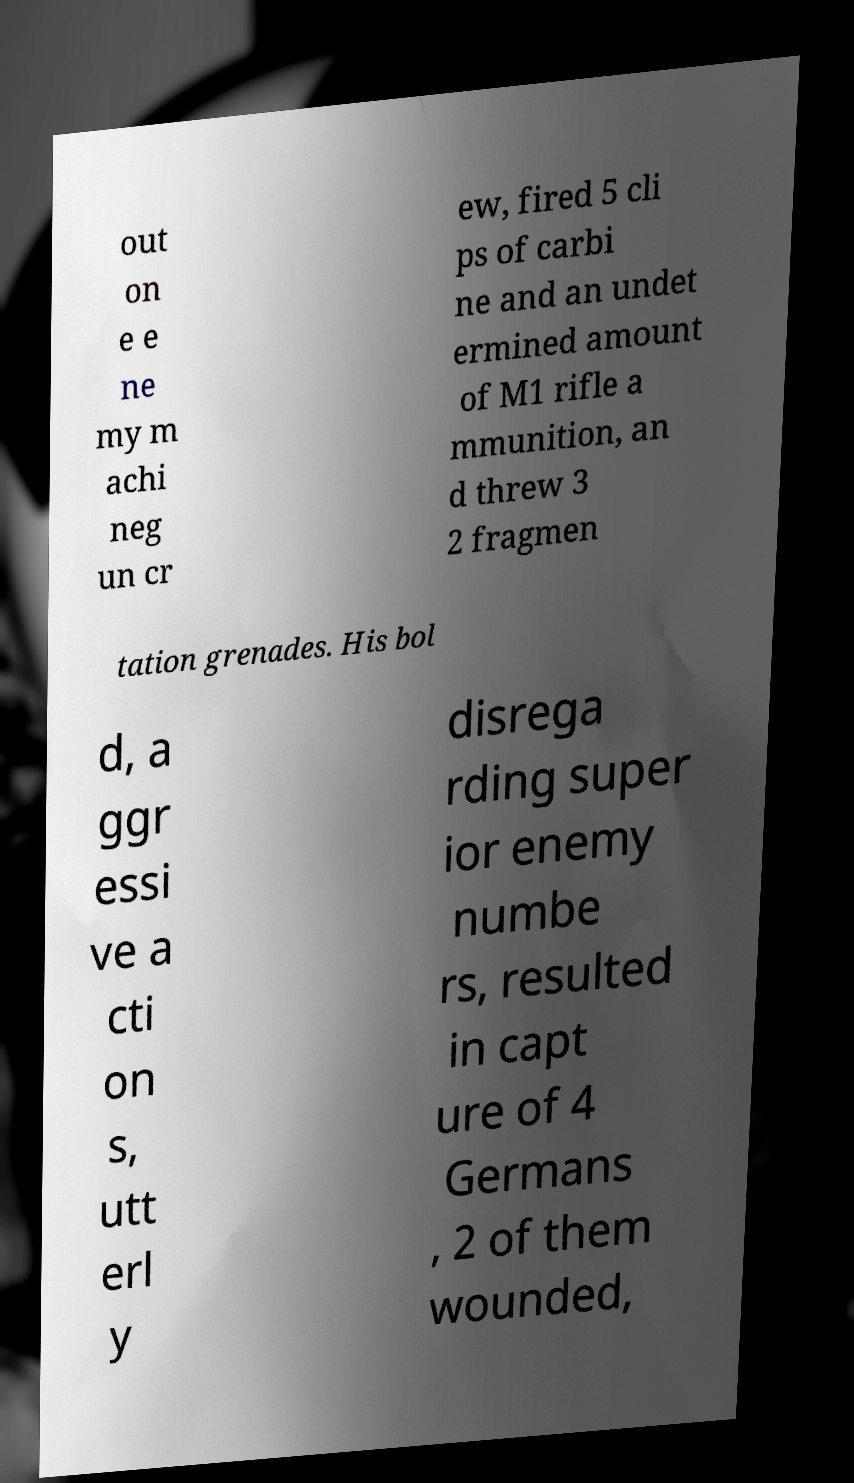Could you extract and type out the text from this image? out on e e ne my m achi neg un cr ew, fired 5 cli ps of carbi ne and an undet ermined amount of M1 rifle a mmunition, an d threw 3 2 fragmen tation grenades. His bol d, a ggr essi ve a cti on s, utt erl y disrega rding super ior enemy numbe rs, resulted in capt ure of 4 Germans , 2 of them wounded, 